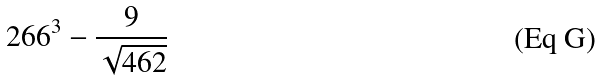<formula> <loc_0><loc_0><loc_500><loc_500>2 6 6 ^ { 3 } - \frac { 9 } { \sqrt { 4 6 2 } }</formula> 